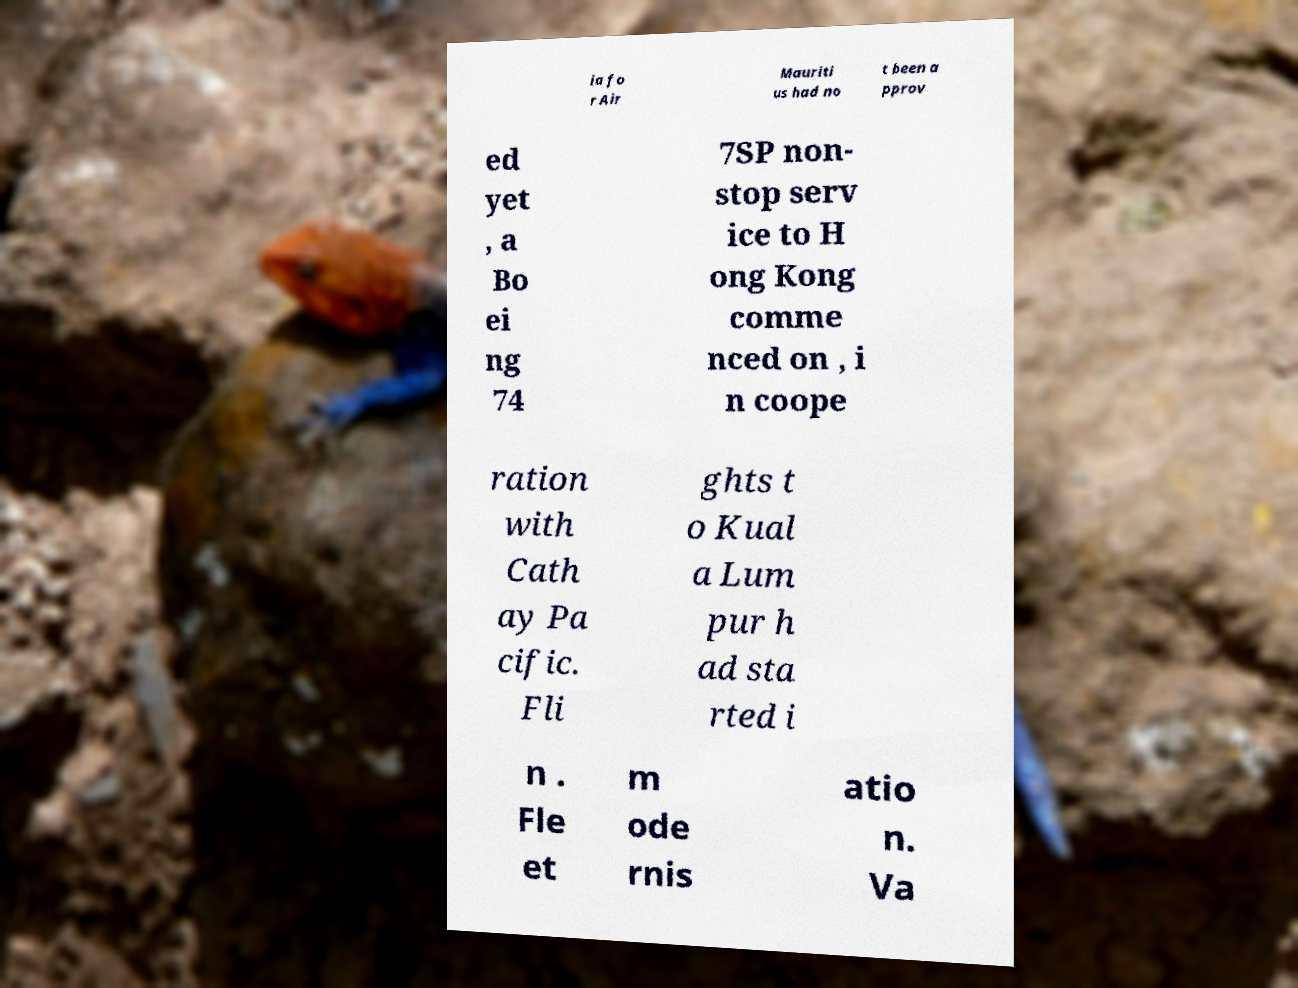Please read and relay the text visible in this image. What does it say? ia fo r Air Mauriti us had no t been a pprov ed yet , a Bo ei ng 74 7SP non- stop serv ice to H ong Kong comme nced on , i n coope ration with Cath ay Pa cific. Fli ghts t o Kual a Lum pur h ad sta rted i n . Fle et m ode rnis atio n. Va 